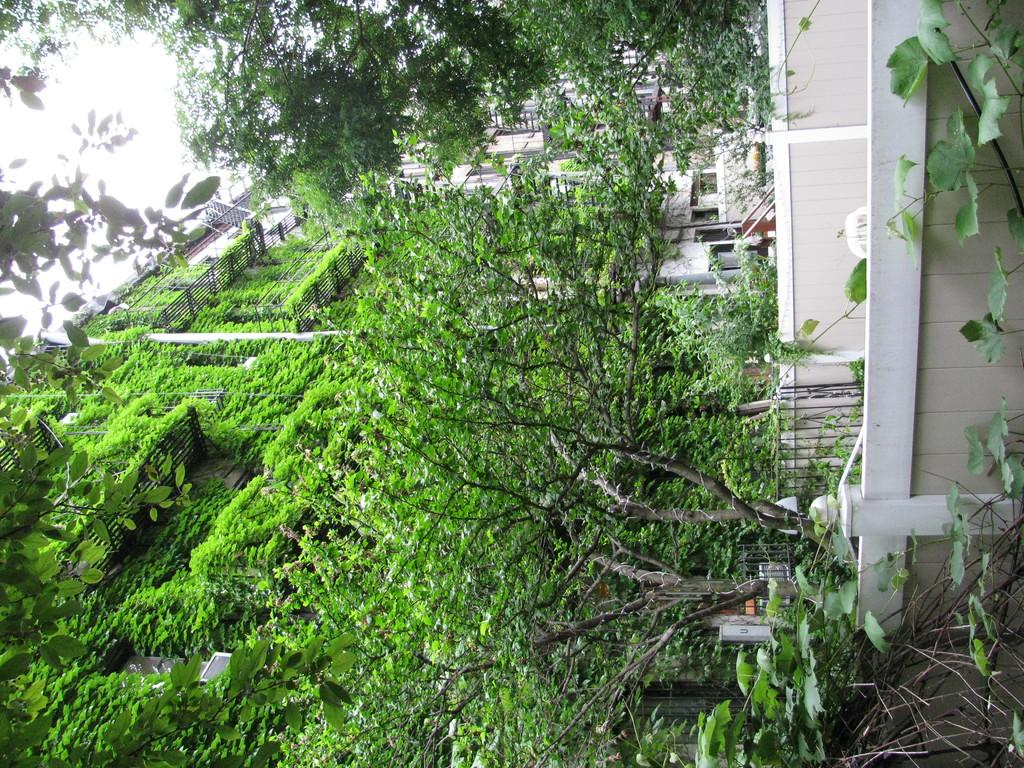What is located in front of the image? There are walls in front of the image. What type of barrier can be seen in the image? There is a metal fence in the image. What structures are visible in the background of the image? There are buildings in the background of the image. What type of vegetation is present in the background of the image? Trees and creepers are visible in the background of the image. What is visible at the top of the image? The sky is visible at the top of the image. Who is the top achiever in the competition depicted in the image? There is no competition or achiever present in the image; it features walls, a metal fence, buildings, trees, creepers, and the sky. What type of doll is sitting on the fence in the image? There is no doll present in the image; it only features walls, a metal fence, buildings, trees, creepers, and the sky. 